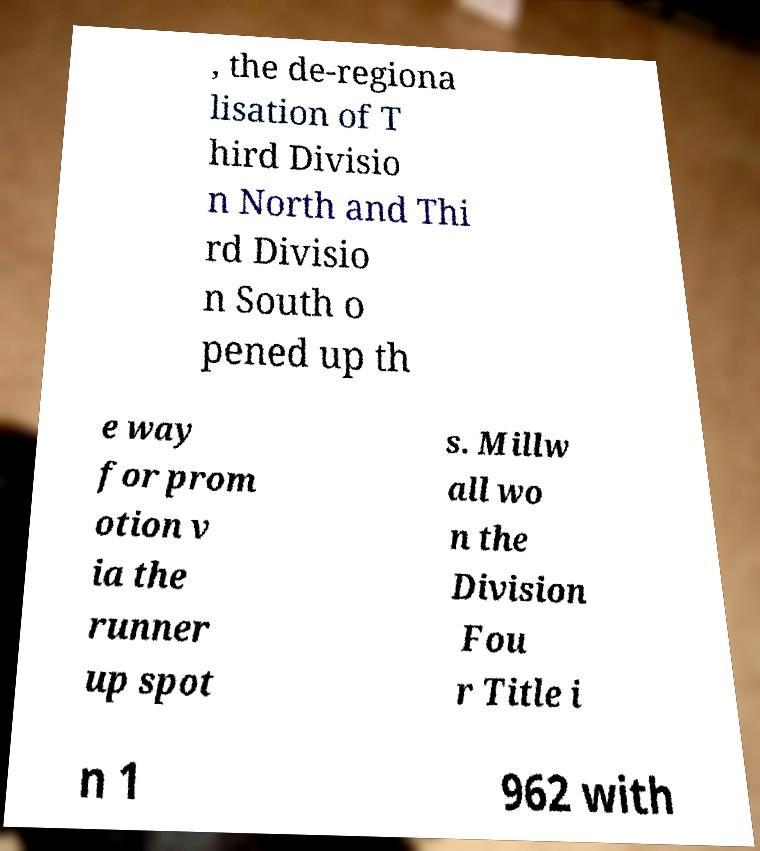There's text embedded in this image that I need extracted. Can you transcribe it verbatim? , the de-regiona lisation of T hird Divisio n North and Thi rd Divisio n South o pened up th e way for prom otion v ia the runner up spot s. Millw all wo n the Division Fou r Title i n 1 962 with 